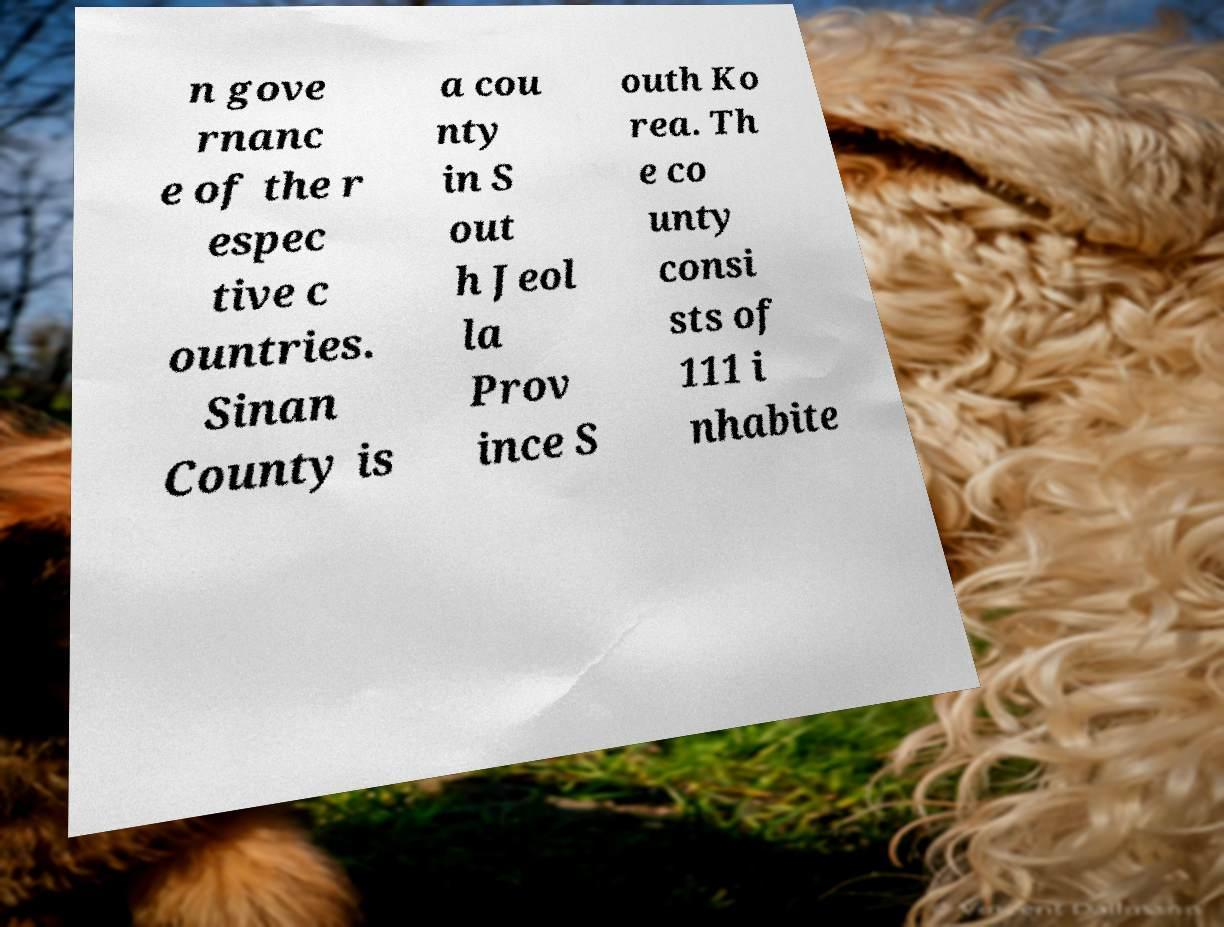Please identify and transcribe the text found in this image. n gove rnanc e of the r espec tive c ountries. Sinan County is a cou nty in S out h Jeol la Prov ince S outh Ko rea. Th e co unty consi sts of 111 i nhabite 